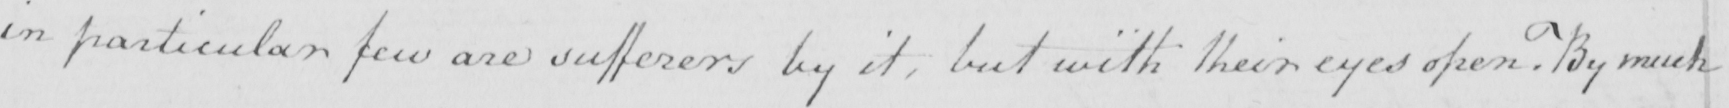Please transcribe the handwritten text in this image. in particular few are sufferers by it , but with their eyes open . By much 